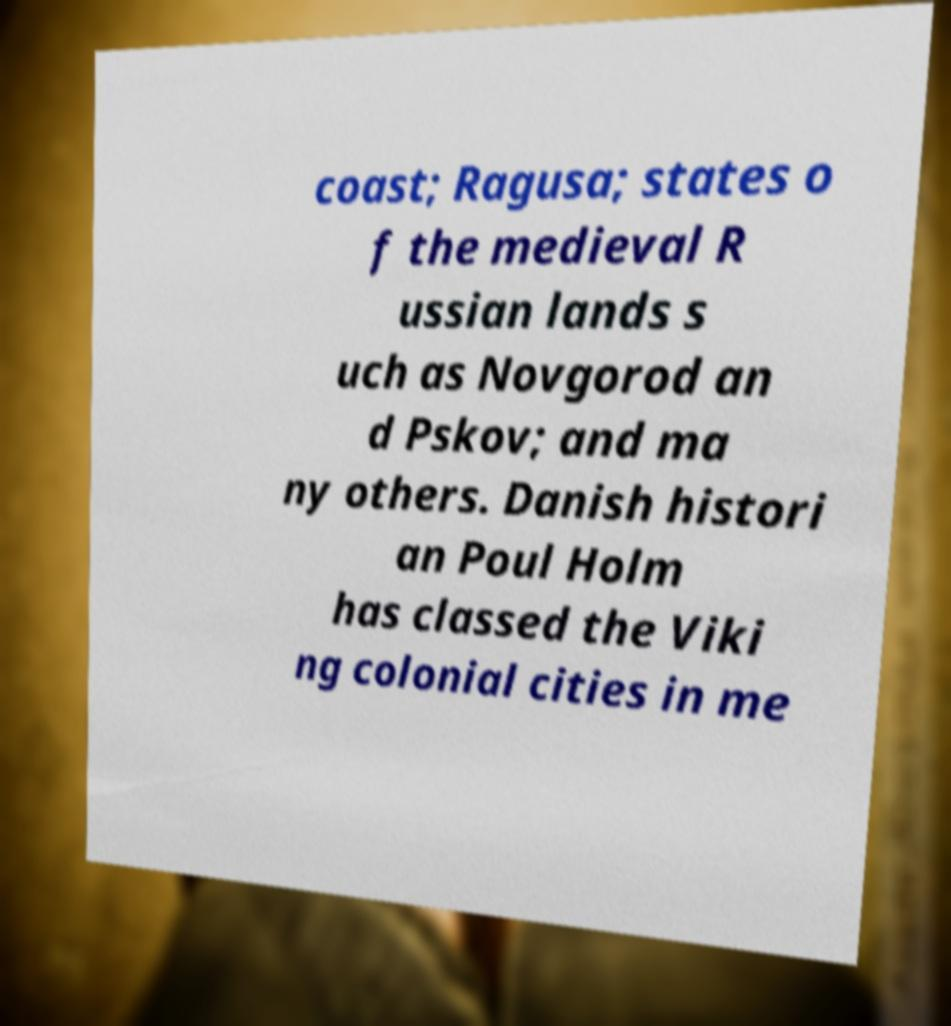Could you assist in decoding the text presented in this image and type it out clearly? coast; Ragusa; states o f the medieval R ussian lands s uch as Novgorod an d Pskov; and ma ny others. Danish histori an Poul Holm has classed the Viki ng colonial cities in me 